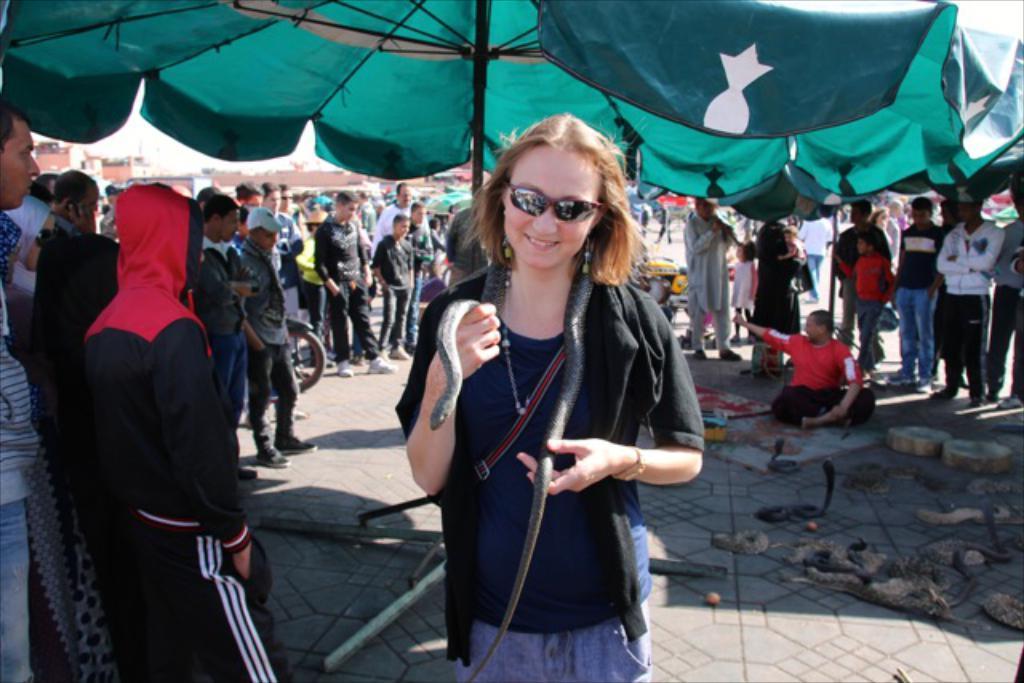Describe this image in one or two sentences. This image consists of a woman holding a snake. She is wearing a black jacket. In this image there are many persons standing. At the bottom, there are many snakes on the ground. 